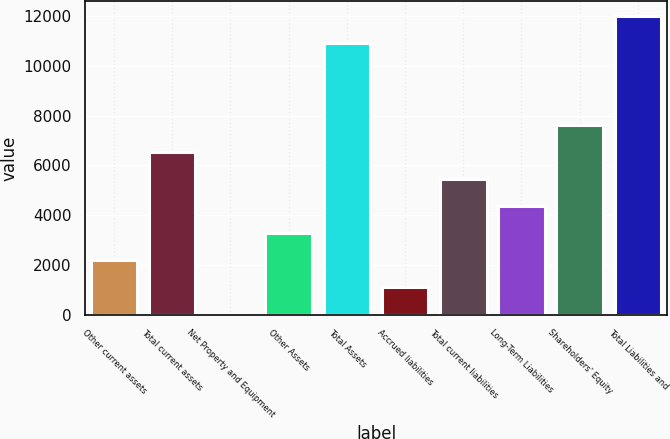Convert chart to OTSL. <chart><loc_0><loc_0><loc_500><loc_500><bar_chart><fcel>Other current assets<fcel>Total current assets<fcel>Net Property and Equipment<fcel>Other Assets<fcel>Total Assets<fcel>Accrued liabilities<fcel>Total current liabilities<fcel>Long-Term Liabilities<fcel>Shareholders' Equity<fcel>Total Liabilities and<nl><fcel>2183.8<fcel>6547.4<fcel>2<fcel>3274.7<fcel>10911<fcel>1092.9<fcel>5456.5<fcel>4365.6<fcel>7638.3<fcel>12001.9<nl></chart> 